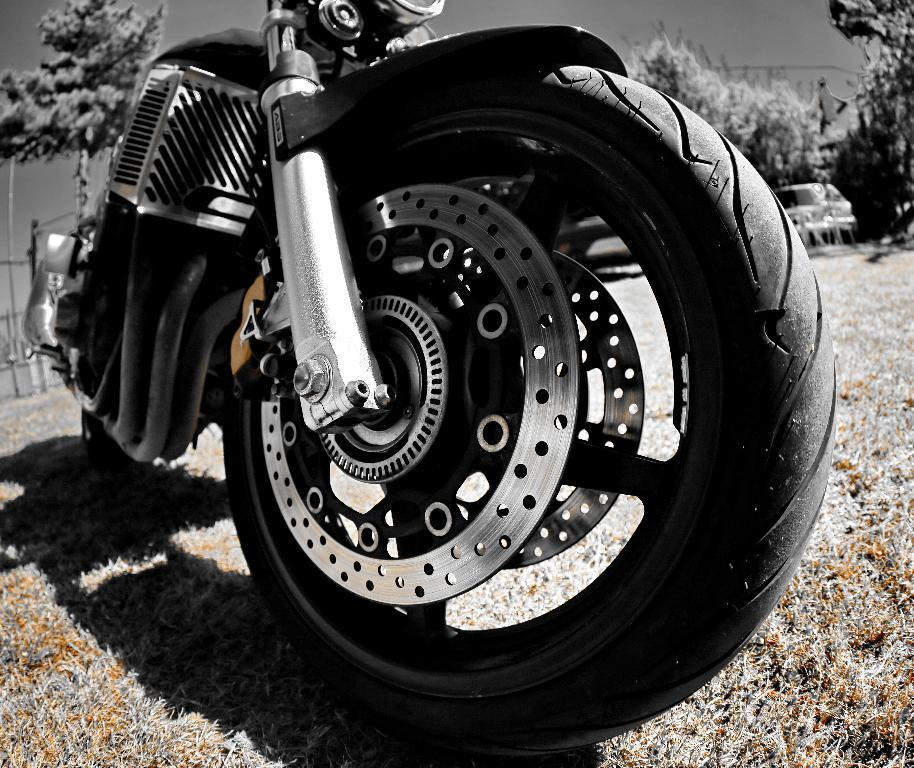What is the main subject in the foreground of the image? There is a motorbike in the foreground of the image. What type of vegetation is present in the foreground of the image? There is grass in the foreground of the image. What can be seen in the background of the image? There are trees, a vehicle, and other objects in the background of the image. How many pizzas are being served on the roof in the image? There is no roof or pizzas present in the image. What type of pleasure can be seen being experienced by the people in the image? There are no people or indication of pleasure in the image. 